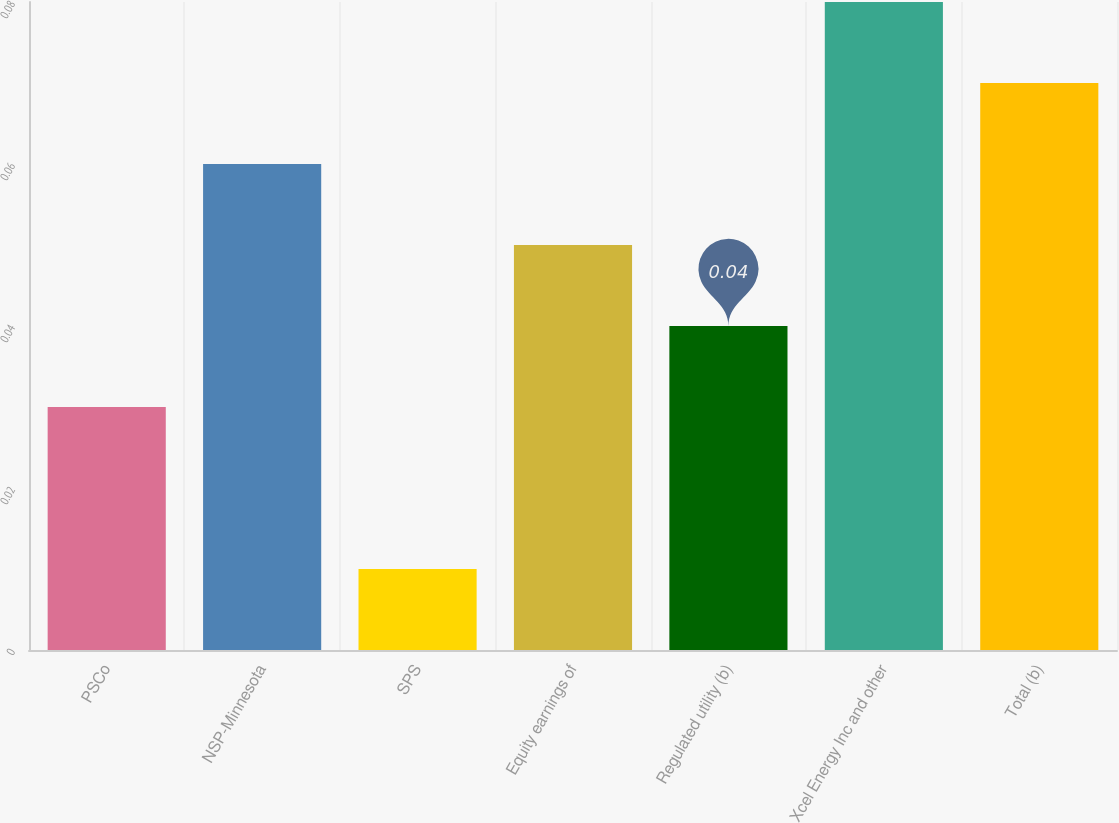Convert chart. <chart><loc_0><loc_0><loc_500><loc_500><bar_chart><fcel>PSCo<fcel>NSP-Minnesota<fcel>SPS<fcel>Equity earnings of<fcel>Regulated utility (b)<fcel>Xcel Energy Inc and other<fcel>Total (b)<nl><fcel>0.03<fcel>0.06<fcel>0.01<fcel>0.05<fcel>0.04<fcel>0.08<fcel>0.07<nl></chart> 